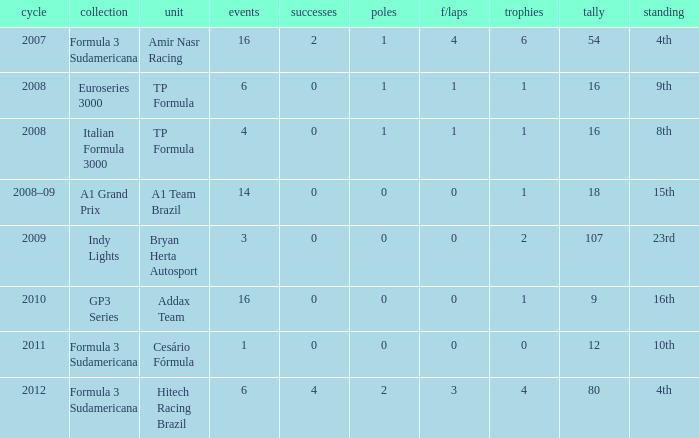How many points did he win in the race with more than 1.0 poles? 80.0. 